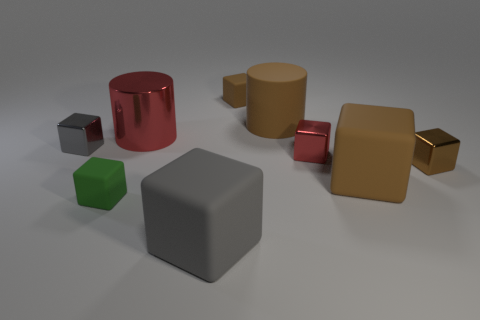Subtract all small green rubber cubes. How many cubes are left? 6 Subtract all green blocks. How many blocks are left? 6 Subtract all gray spheres. How many brown blocks are left? 3 Subtract 6 blocks. How many blocks are left? 1 Subtract 0 gray cylinders. How many objects are left? 9 Subtract all cylinders. How many objects are left? 7 Subtract all blue cylinders. Subtract all gray balls. How many cylinders are left? 2 Subtract all gray metallic spheres. Subtract all small red things. How many objects are left? 8 Add 7 big matte things. How many big matte things are left? 10 Add 1 small gray things. How many small gray things exist? 2 